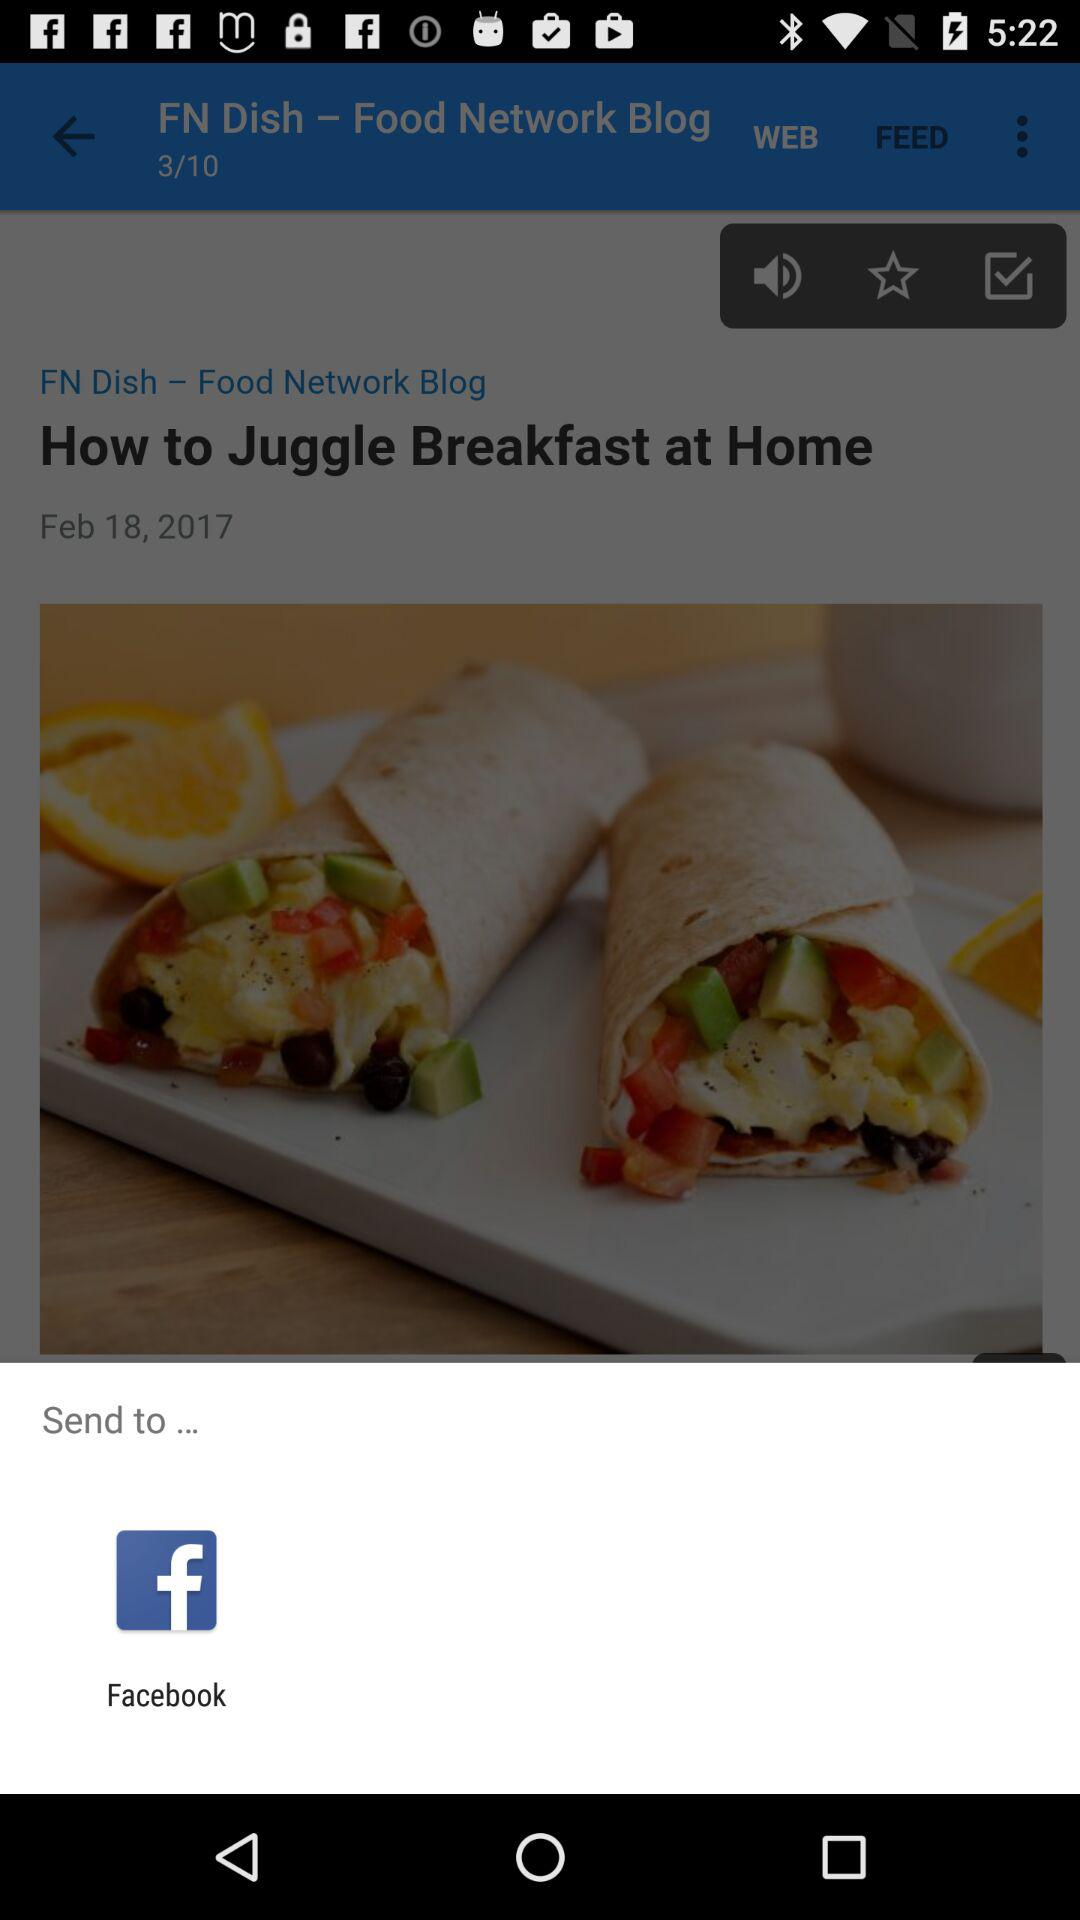Through what application can we send the post? You can send the post through "Facebook". 